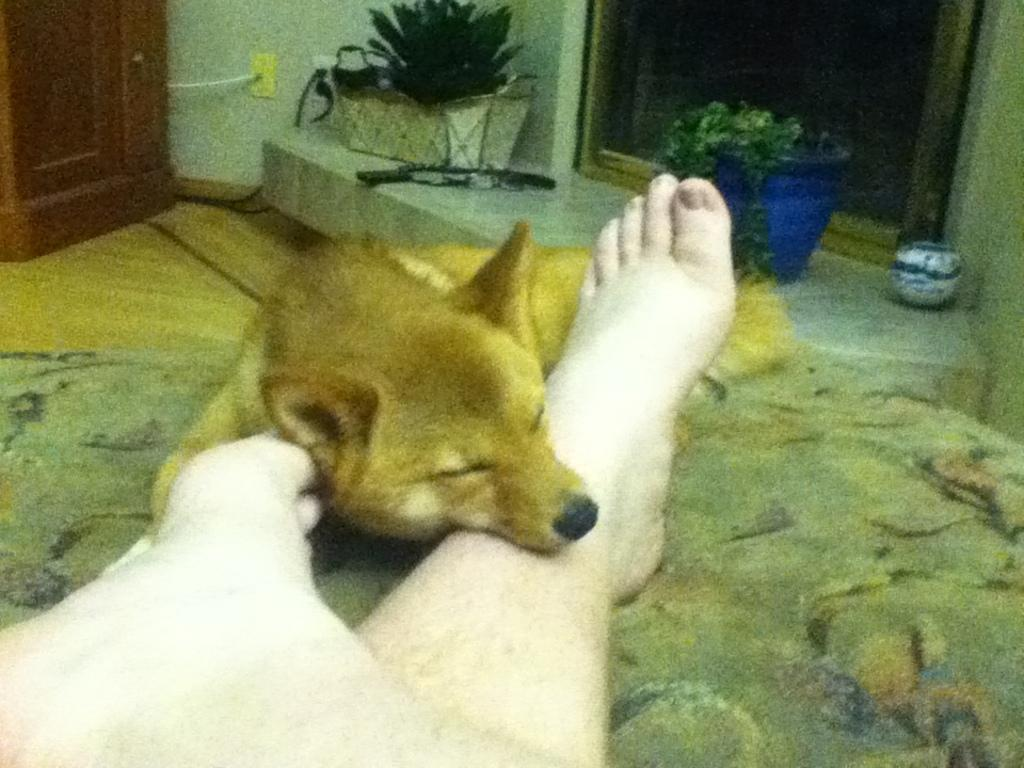What type of animal can be seen in the image? There is a dog in the image. What else is visible in the image besides the dog? Human legs and plants are visible in the image. Can you describe the door in the image? There is a door in the image. What type of suit is the dog wearing in the image? There is no suit present in the image, as the dog is not wearing any clothing. 